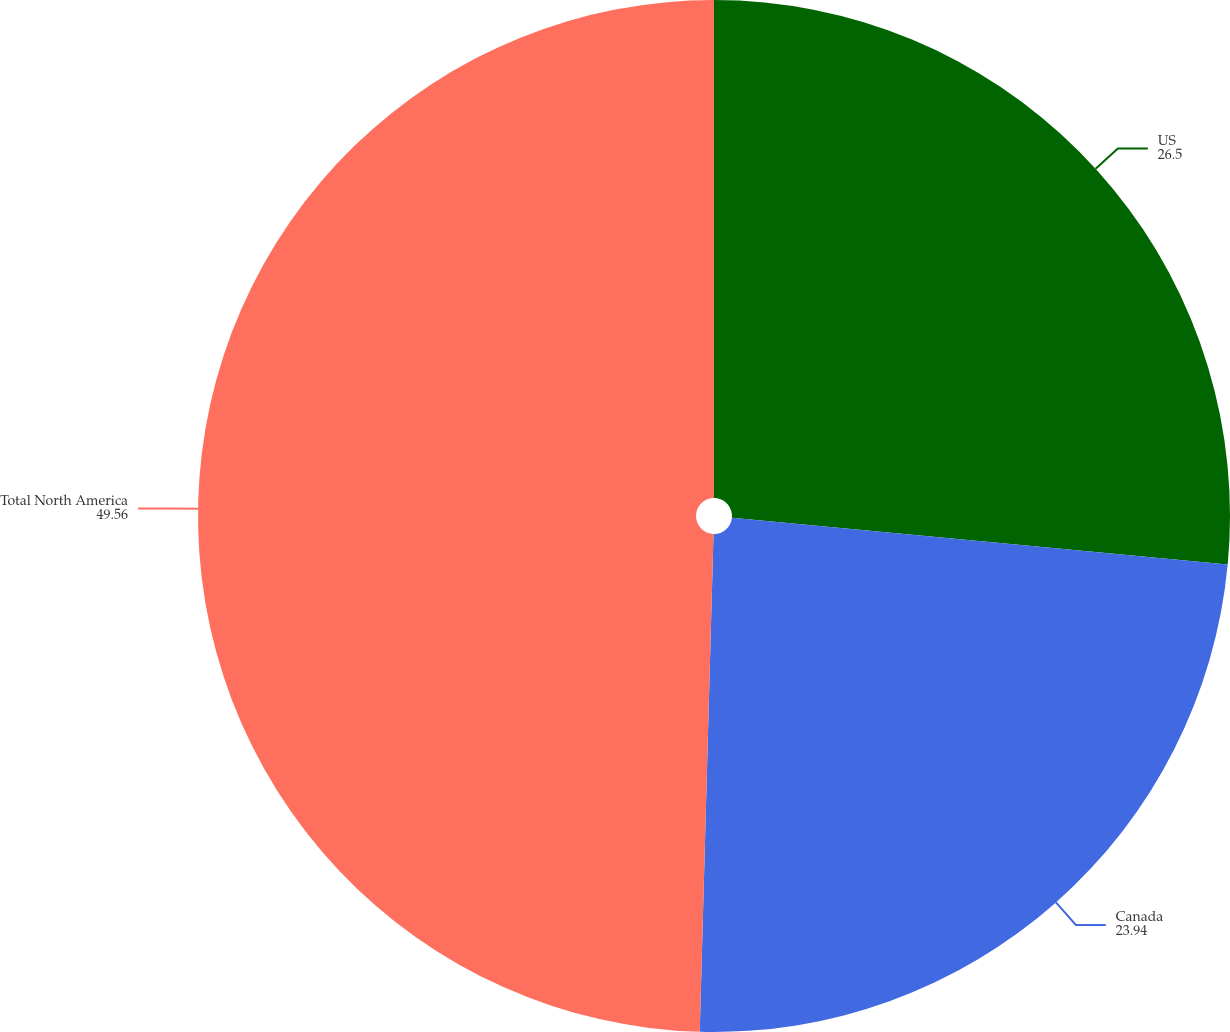Convert chart to OTSL. <chart><loc_0><loc_0><loc_500><loc_500><pie_chart><fcel>US<fcel>Canada<fcel>Total North America<nl><fcel>26.5%<fcel>23.94%<fcel>49.56%<nl></chart> 